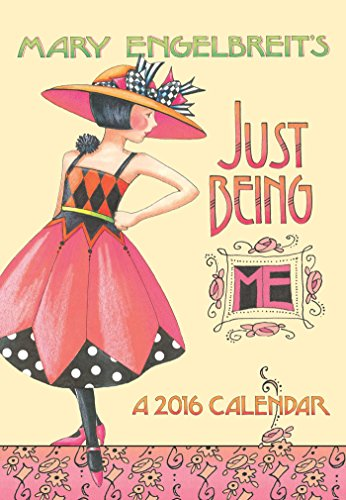Is this a digital technology book? No, this book is not related to digital technology. It's a printed pocket planner designed for physical use to keep track of daily schedules and appointments. 